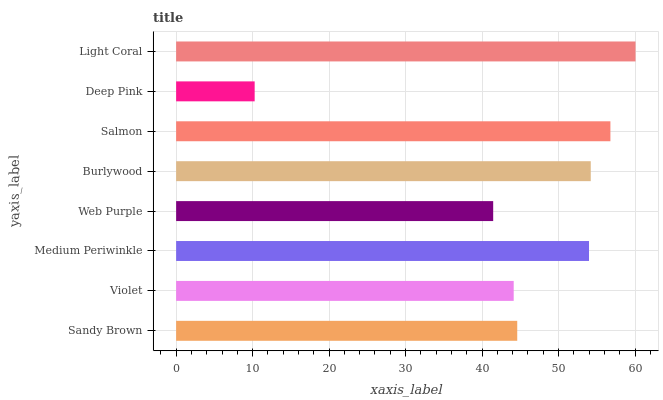Is Deep Pink the minimum?
Answer yes or no. Yes. Is Light Coral the maximum?
Answer yes or no. Yes. Is Violet the minimum?
Answer yes or no. No. Is Violet the maximum?
Answer yes or no. No. Is Sandy Brown greater than Violet?
Answer yes or no. Yes. Is Violet less than Sandy Brown?
Answer yes or no. Yes. Is Violet greater than Sandy Brown?
Answer yes or no. No. Is Sandy Brown less than Violet?
Answer yes or no. No. Is Medium Periwinkle the high median?
Answer yes or no. Yes. Is Sandy Brown the low median?
Answer yes or no. Yes. Is Deep Pink the high median?
Answer yes or no. No. Is Burlywood the low median?
Answer yes or no. No. 